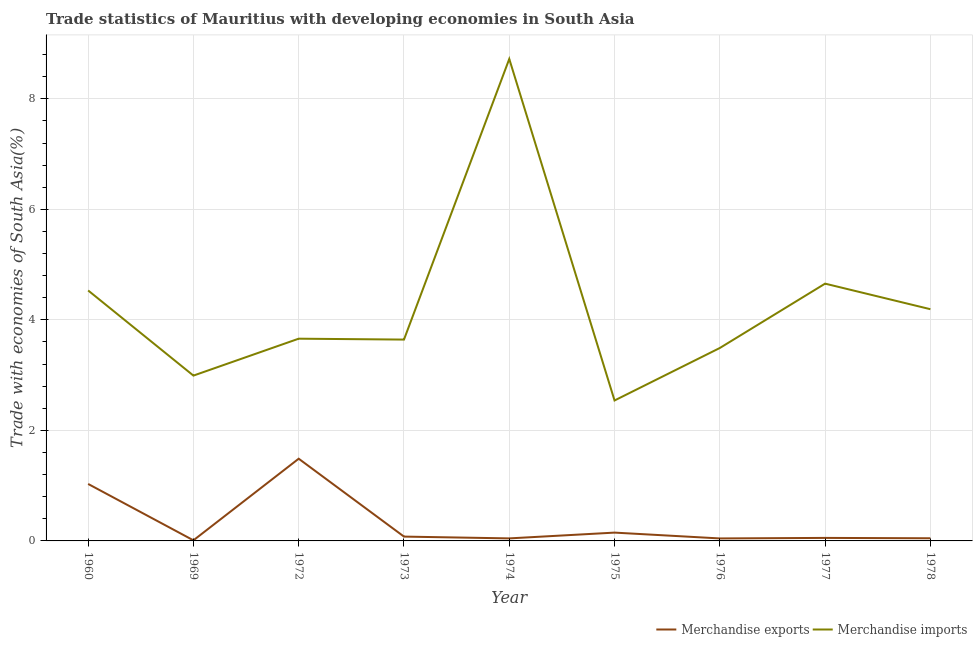What is the merchandise exports in 1974?
Keep it short and to the point. 0.05. Across all years, what is the maximum merchandise imports?
Your answer should be compact. 8.72. Across all years, what is the minimum merchandise exports?
Ensure brevity in your answer.  0.01. In which year was the merchandise exports minimum?
Keep it short and to the point. 1969. What is the total merchandise imports in the graph?
Provide a short and direct response. 38.43. What is the difference between the merchandise imports in 1974 and that in 1977?
Your response must be concise. 4.07. What is the difference between the merchandise imports in 1969 and the merchandise exports in 1977?
Your response must be concise. 2.94. What is the average merchandise imports per year?
Make the answer very short. 4.27. In the year 1974, what is the difference between the merchandise imports and merchandise exports?
Your response must be concise. 8.68. In how many years, is the merchandise exports greater than 6.4 %?
Give a very brief answer. 0. What is the ratio of the merchandise imports in 1974 to that in 1975?
Your response must be concise. 3.43. Is the merchandise exports in 1973 less than that in 1978?
Your answer should be compact. No. Is the difference between the merchandise exports in 1960 and 1973 greater than the difference between the merchandise imports in 1960 and 1973?
Provide a short and direct response. Yes. What is the difference between the highest and the second highest merchandise imports?
Offer a very short reply. 4.07. What is the difference between the highest and the lowest merchandise imports?
Keep it short and to the point. 6.18. In how many years, is the merchandise imports greater than the average merchandise imports taken over all years?
Your answer should be compact. 3. Is the sum of the merchandise imports in 1960 and 1973 greater than the maximum merchandise exports across all years?
Give a very brief answer. Yes. Does the merchandise exports monotonically increase over the years?
Your answer should be compact. No. Is the merchandise imports strictly greater than the merchandise exports over the years?
Give a very brief answer. Yes. Is the merchandise imports strictly less than the merchandise exports over the years?
Keep it short and to the point. No. Does the graph contain any zero values?
Keep it short and to the point. No. How many legend labels are there?
Your answer should be compact. 2. How are the legend labels stacked?
Give a very brief answer. Horizontal. What is the title of the graph?
Your answer should be compact. Trade statistics of Mauritius with developing economies in South Asia. Does "Merchandise imports" appear as one of the legend labels in the graph?
Ensure brevity in your answer.  Yes. What is the label or title of the Y-axis?
Your response must be concise. Trade with economies of South Asia(%). What is the Trade with economies of South Asia(%) of Merchandise exports in 1960?
Provide a short and direct response. 1.03. What is the Trade with economies of South Asia(%) of Merchandise imports in 1960?
Your answer should be very brief. 4.53. What is the Trade with economies of South Asia(%) in Merchandise exports in 1969?
Offer a terse response. 0.01. What is the Trade with economies of South Asia(%) of Merchandise imports in 1969?
Make the answer very short. 2.99. What is the Trade with economies of South Asia(%) of Merchandise exports in 1972?
Your response must be concise. 1.49. What is the Trade with economies of South Asia(%) of Merchandise imports in 1972?
Your answer should be compact. 3.66. What is the Trade with economies of South Asia(%) in Merchandise exports in 1973?
Your response must be concise. 0.08. What is the Trade with economies of South Asia(%) of Merchandise imports in 1973?
Keep it short and to the point. 3.64. What is the Trade with economies of South Asia(%) of Merchandise exports in 1974?
Your answer should be very brief. 0.05. What is the Trade with economies of South Asia(%) in Merchandise imports in 1974?
Keep it short and to the point. 8.72. What is the Trade with economies of South Asia(%) of Merchandise exports in 1975?
Keep it short and to the point. 0.15. What is the Trade with economies of South Asia(%) of Merchandise imports in 1975?
Make the answer very short. 2.54. What is the Trade with economies of South Asia(%) of Merchandise exports in 1976?
Provide a succinct answer. 0.05. What is the Trade with economies of South Asia(%) of Merchandise imports in 1976?
Ensure brevity in your answer.  3.49. What is the Trade with economies of South Asia(%) of Merchandise exports in 1977?
Provide a succinct answer. 0.05. What is the Trade with economies of South Asia(%) of Merchandise imports in 1977?
Make the answer very short. 4.66. What is the Trade with economies of South Asia(%) of Merchandise exports in 1978?
Keep it short and to the point. 0.05. What is the Trade with economies of South Asia(%) in Merchandise imports in 1978?
Offer a very short reply. 4.19. Across all years, what is the maximum Trade with economies of South Asia(%) in Merchandise exports?
Offer a very short reply. 1.49. Across all years, what is the maximum Trade with economies of South Asia(%) of Merchandise imports?
Provide a succinct answer. 8.72. Across all years, what is the minimum Trade with economies of South Asia(%) in Merchandise exports?
Offer a very short reply. 0.01. Across all years, what is the minimum Trade with economies of South Asia(%) in Merchandise imports?
Ensure brevity in your answer.  2.54. What is the total Trade with economies of South Asia(%) in Merchandise exports in the graph?
Give a very brief answer. 2.95. What is the total Trade with economies of South Asia(%) of Merchandise imports in the graph?
Give a very brief answer. 38.43. What is the difference between the Trade with economies of South Asia(%) in Merchandise exports in 1960 and that in 1969?
Your answer should be very brief. 1.02. What is the difference between the Trade with economies of South Asia(%) in Merchandise imports in 1960 and that in 1969?
Offer a terse response. 1.54. What is the difference between the Trade with economies of South Asia(%) in Merchandise exports in 1960 and that in 1972?
Your response must be concise. -0.46. What is the difference between the Trade with economies of South Asia(%) in Merchandise imports in 1960 and that in 1972?
Offer a terse response. 0.87. What is the difference between the Trade with economies of South Asia(%) in Merchandise exports in 1960 and that in 1973?
Make the answer very short. 0.95. What is the difference between the Trade with economies of South Asia(%) of Merchandise imports in 1960 and that in 1973?
Offer a terse response. 0.89. What is the difference between the Trade with economies of South Asia(%) of Merchandise exports in 1960 and that in 1974?
Your response must be concise. 0.99. What is the difference between the Trade with economies of South Asia(%) in Merchandise imports in 1960 and that in 1974?
Keep it short and to the point. -4.19. What is the difference between the Trade with economies of South Asia(%) in Merchandise exports in 1960 and that in 1975?
Ensure brevity in your answer.  0.88. What is the difference between the Trade with economies of South Asia(%) in Merchandise imports in 1960 and that in 1975?
Ensure brevity in your answer.  1.99. What is the difference between the Trade with economies of South Asia(%) of Merchandise exports in 1960 and that in 1976?
Offer a very short reply. 0.99. What is the difference between the Trade with economies of South Asia(%) of Merchandise imports in 1960 and that in 1976?
Ensure brevity in your answer.  1.04. What is the difference between the Trade with economies of South Asia(%) of Merchandise exports in 1960 and that in 1977?
Make the answer very short. 0.98. What is the difference between the Trade with economies of South Asia(%) in Merchandise imports in 1960 and that in 1977?
Offer a terse response. -0.12. What is the difference between the Trade with economies of South Asia(%) in Merchandise exports in 1960 and that in 1978?
Provide a short and direct response. 0.98. What is the difference between the Trade with economies of South Asia(%) of Merchandise imports in 1960 and that in 1978?
Give a very brief answer. 0.34. What is the difference between the Trade with economies of South Asia(%) of Merchandise exports in 1969 and that in 1972?
Your response must be concise. -1.48. What is the difference between the Trade with economies of South Asia(%) in Merchandise imports in 1969 and that in 1972?
Make the answer very short. -0.67. What is the difference between the Trade with economies of South Asia(%) of Merchandise exports in 1969 and that in 1973?
Offer a very short reply. -0.07. What is the difference between the Trade with economies of South Asia(%) of Merchandise imports in 1969 and that in 1973?
Give a very brief answer. -0.65. What is the difference between the Trade with economies of South Asia(%) of Merchandise exports in 1969 and that in 1974?
Offer a very short reply. -0.04. What is the difference between the Trade with economies of South Asia(%) in Merchandise imports in 1969 and that in 1974?
Keep it short and to the point. -5.73. What is the difference between the Trade with economies of South Asia(%) of Merchandise exports in 1969 and that in 1975?
Your answer should be very brief. -0.14. What is the difference between the Trade with economies of South Asia(%) in Merchandise imports in 1969 and that in 1975?
Give a very brief answer. 0.45. What is the difference between the Trade with economies of South Asia(%) in Merchandise exports in 1969 and that in 1976?
Offer a terse response. -0.03. What is the difference between the Trade with economies of South Asia(%) of Merchandise imports in 1969 and that in 1976?
Offer a terse response. -0.5. What is the difference between the Trade with economies of South Asia(%) of Merchandise exports in 1969 and that in 1977?
Give a very brief answer. -0.04. What is the difference between the Trade with economies of South Asia(%) in Merchandise imports in 1969 and that in 1977?
Ensure brevity in your answer.  -1.66. What is the difference between the Trade with economies of South Asia(%) in Merchandise exports in 1969 and that in 1978?
Ensure brevity in your answer.  -0.04. What is the difference between the Trade with economies of South Asia(%) of Merchandise imports in 1969 and that in 1978?
Give a very brief answer. -1.2. What is the difference between the Trade with economies of South Asia(%) in Merchandise exports in 1972 and that in 1973?
Provide a short and direct response. 1.41. What is the difference between the Trade with economies of South Asia(%) in Merchandise imports in 1972 and that in 1973?
Give a very brief answer. 0.02. What is the difference between the Trade with economies of South Asia(%) of Merchandise exports in 1972 and that in 1974?
Your response must be concise. 1.44. What is the difference between the Trade with economies of South Asia(%) of Merchandise imports in 1972 and that in 1974?
Offer a terse response. -5.06. What is the difference between the Trade with economies of South Asia(%) of Merchandise exports in 1972 and that in 1975?
Provide a short and direct response. 1.34. What is the difference between the Trade with economies of South Asia(%) in Merchandise imports in 1972 and that in 1975?
Provide a succinct answer. 1.12. What is the difference between the Trade with economies of South Asia(%) in Merchandise exports in 1972 and that in 1976?
Your answer should be very brief. 1.44. What is the difference between the Trade with economies of South Asia(%) in Merchandise imports in 1972 and that in 1976?
Make the answer very short. 0.17. What is the difference between the Trade with economies of South Asia(%) in Merchandise exports in 1972 and that in 1977?
Offer a very short reply. 1.43. What is the difference between the Trade with economies of South Asia(%) in Merchandise imports in 1972 and that in 1977?
Your response must be concise. -1. What is the difference between the Trade with economies of South Asia(%) in Merchandise exports in 1972 and that in 1978?
Make the answer very short. 1.44. What is the difference between the Trade with economies of South Asia(%) in Merchandise imports in 1972 and that in 1978?
Offer a very short reply. -0.53. What is the difference between the Trade with economies of South Asia(%) in Merchandise exports in 1973 and that in 1974?
Your answer should be very brief. 0.03. What is the difference between the Trade with economies of South Asia(%) in Merchandise imports in 1973 and that in 1974?
Your response must be concise. -5.08. What is the difference between the Trade with economies of South Asia(%) of Merchandise exports in 1973 and that in 1975?
Make the answer very short. -0.07. What is the difference between the Trade with economies of South Asia(%) of Merchandise imports in 1973 and that in 1975?
Keep it short and to the point. 1.1. What is the difference between the Trade with economies of South Asia(%) in Merchandise exports in 1973 and that in 1976?
Your response must be concise. 0.03. What is the difference between the Trade with economies of South Asia(%) in Merchandise imports in 1973 and that in 1976?
Offer a very short reply. 0.15. What is the difference between the Trade with economies of South Asia(%) in Merchandise exports in 1973 and that in 1977?
Give a very brief answer. 0.02. What is the difference between the Trade with economies of South Asia(%) in Merchandise imports in 1973 and that in 1977?
Ensure brevity in your answer.  -1.01. What is the difference between the Trade with economies of South Asia(%) in Merchandise exports in 1973 and that in 1978?
Provide a short and direct response. 0.03. What is the difference between the Trade with economies of South Asia(%) of Merchandise imports in 1973 and that in 1978?
Make the answer very short. -0.55. What is the difference between the Trade with economies of South Asia(%) in Merchandise exports in 1974 and that in 1975?
Your response must be concise. -0.1. What is the difference between the Trade with economies of South Asia(%) in Merchandise imports in 1974 and that in 1975?
Your answer should be compact. 6.18. What is the difference between the Trade with economies of South Asia(%) in Merchandise exports in 1974 and that in 1976?
Your answer should be very brief. 0. What is the difference between the Trade with economies of South Asia(%) in Merchandise imports in 1974 and that in 1976?
Your response must be concise. 5.23. What is the difference between the Trade with economies of South Asia(%) in Merchandise exports in 1974 and that in 1977?
Provide a short and direct response. -0.01. What is the difference between the Trade with economies of South Asia(%) in Merchandise imports in 1974 and that in 1977?
Your answer should be compact. 4.07. What is the difference between the Trade with economies of South Asia(%) of Merchandise exports in 1974 and that in 1978?
Keep it short and to the point. -0. What is the difference between the Trade with economies of South Asia(%) in Merchandise imports in 1974 and that in 1978?
Make the answer very short. 4.53. What is the difference between the Trade with economies of South Asia(%) of Merchandise exports in 1975 and that in 1976?
Offer a terse response. 0.11. What is the difference between the Trade with economies of South Asia(%) in Merchandise imports in 1975 and that in 1976?
Ensure brevity in your answer.  -0.95. What is the difference between the Trade with economies of South Asia(%) of Merchandise exports in 1975 and that in 1977?
Make the answer very short. 0.1. What is the difference between the Trade with economies of South Asia(%) in Merchandise imports in 1975 and that in 1977?
Ensure brevity in your answer.  -2.11. What is the difference between the Trade with economies of South Asia(%) in Merchandise exports in 1975 and that in 1978?
Your answer should be compact. 0.1. What is the difference between the Trade with economies of South Asia(%) in Merchandise imports in 1975 and that in 1978?
Offer a very short reply. -1.65. What is the difference between the Trade with economies of South Asia(%) in Merchandise exports in 1976 and that in 1977?
Your response must be concise. -0.01. What is the difference between the Trade with economies of South Asia(%) of Merchandise imports in 1976 and that in 1977?
Your answer should be very brief. -1.16. What is the difference between the Trade with economies of South Asia(%) of Merchandise exports in 1976 and that in 1978?
Your answer should be very brief. -0. What is the difference between the Trade with economies of South Asia(%) in Merchandise imports in 1976 and that in 1978?
Your response must be concise. -0.7. What is the difference between the Trade with economies of South Asia(%) of Merchandise exports in 1977 and that in 1978?
Ensure brevity in your answer.  0.01. What is the difference between the Trade with economies of South Asia(%) in Merchandise imports in 1977 and that in 1978?
Your answer should be compact. 0.46. What is the difference between the Trade with economies of South Asia(%) in Merchandise exports in 1960 and the Trade with economies of South Asia(%) in Merchandise imports in 1969?
Offer a terse response. -1.96. What is the difference between the Trade with economies of South Asia(%) in Merchandise exports in 1960 and the Trade with economies of South Asia(%) in Merchandise imports in 1972?
Make the answer very short. -2.63. What is the difference between the Trade with economies of South Asia(%) of Merchandise exports in 1960 and the Trade with economies of South Asia(%) of Merchandise imports in 1973?
Your response must be concise. -2.61. What is the difference between the Trade with economies of South Asia(%) in Merchandise exports in 1960 and the Trade with economies of South Asia(%) in Merchandise imports in 1974?
Provide a short and direct response. -7.69. What is the difference between the Trade with economies of South Asia(%) in Merchandise exports in 1960 and the Trade with economies of South Asia(%) in Merchandise imports in 1975?
Give a very brief answer. -1.51. What is the difference between the Trade with economies of South Asia(%) in Merchandise exports in 1960 and the Trade with economies of South Asia(%) in Merchandise imports in 1976?
Ensure brevity in your answer.  -2.46. What is the difference between the Trade with economies of South Asia(%) in Merchandise exports in 1960 and the Trade with economies of South Asia(%) in Merchandise imports in 1977?
Provide a short and direct response. -3.62. What is the difference between the Trade with economies of South Asia(%) of Merchandise exports in 1960 and the Trade with economies of South Asia(%) of Merchandise imports in 1978?
Your response must be concise. -3.16. What is the difference between the Trade with economies of South Asia(%) of Merchandise exports in 1969 and the Trade with economies of South Asia(%) of Merchandise imports in 1972?
Offer a terse response. -3.65. What is the difference between the Trade with economies of South Asia(%) in Merchandise exports in 1969 and the Trade with economies of South Asia(%) in Merchandise imports in 1973?
Provide a short and direct response. -3.63. What is the difference between the Trade with economies of South Asia(%) of Merchandise exports in 1969 and the Trade with economies of South Asia(%) of Merchandise imports in 1974?
Give a very brief answer. -8.71. What is the difference between the Trade with economies of South Asia(%) of Merchandise exports in 1969 and the Trade with economies of South Asia(%) of Merchandise imports in 1975?
Your answer should be compact. -2.53. What is the difference between the Trade with economies of South Asia(%) of Merchandise exports in 1969 and the Trade with economies of South Asia(%) of Merchandise imports in 1976?
Provide a short and direct response. -3.48. What is the difference between the Trade with economies of South Asia(%) of Merchandise exports in 1969 and the Trade with economies of South Asia(%) of Merchandise imports in 1977?
Provide a succinct answer. -4.64. What is the difference between the Trade with economies of South Asia(%) of Merchandise exports in 1969 and the Trade with economies of South Asia(%) of Merchandise imports in 1978?
Your response must be concise. -4.18. What is the difference between the Trade with economies of South Asia(%) in Merchandise exports in 1972 and the Trade with economies of South Asia(%) in Merchandise imports in 1973?
Offer a very short reply. -2.16. What is the difference between the Trade with economies of South Asia(%) in Merchandise exports in 1972 and the Trade with economies of South Asia(%) in Merchandise imports in 1974?
Offer a very short reply. -7.23. What is the difference between the Trade with economies of South Asia(%) in Merchandise exports in 1972 and the Trade with economies of South Asia(%) in Merchandise imports in 1975?
Your answer should be compact. -1.05. What is the difference between the Trade with economies of South Asia(%) in Merchandise exports in 1972 and the Trade with economies of South Asia(%) in Merchandise imports in 1976?
Provide a short and direct response. -2. What is the difference between the Trade with economies of South Asia(%) in Merchandise exports in 1972 and the Trade with economies of South Asia(%) in Merchandise imports in 1977?
Your answer should be very brief. -3.17. What is the difference between the Trade with economies of South Asia(%) of Merchandise exports in 1972 and the Trade with economies of South Asia(%) of Merchandise imports in 1978?
Ensure brevity in your answer.  -2.71. What is the difference between the Trade with economies of South Asia(%) of Merchandise exports in 1973 and the Trade with economies of South Asia(%) of Merchandise imports in 1974?
Provide a succinct answer. -8.64. What is the difference between the Trade with economies of South Asia(%) in Merchandise exports in 1973 and the Trade with economies of South Asia(%) in Merchandise imports in 1975?
Your response must be concise. -2.46. What is the difference between the Trade with economies of South Asia(%) in Merchandise exports in 1973 and the Trade with economies of South Asia(%) in Merchandise imports in 1976?
Ensure brevity in your answer.  -3.41. What is the difference between the Trade with economies of South Asia(%) in Merchandise exports in 1973 and the Trade with economies of South Asia(%) in Merchandise imports in 1977?
Offer a terse response. -4.58. What is the difference between the Trade with economies of South Asia(%) of Merchandise exports in 1973 and the Trade with economies of South Asia(%) of Merchandise imports in 1978?
Your response must be concise. -4.11. What is the difference between the Trade with economies of South Asia(%) in Merchandise exports in 1974 and the Trade with economies of South Asia(%) in Merchandise imports in 1975?
Your answer should be very brief. -2.5. What is the difference between the Trade with economies of South Asia(%) in Merchandise exports in 1974 and the Trade with economies of South Asia(%) in Merchandise imports in 1976?
Offer a terse response. -3.45. What is the difference between the Trade with economies of South Asia(%) of Merchandise exports in 1974 and the Trade with economies of South Asia(%) of Merchandise imports in 1977?
Ensure brevity in your answer.  -4.61. What is the difference between the Trade with economies of South Asia(%) of Merchandise exports in 1974 and the Trade with economies of South Asia(%) of Merchandise imports in 1978?
Make the answer very short. -4.15. What is the difference between the Trade with economies of South Asia(%) of Merchandise exports in 1975 and the Trade with economies of South Asia(%) of Merchandise imports in 1976?
Keep it short and to the point. -3.34. What is the difference between the Trade with economies of South Asia(%) of Merchandise exports in 1975 and the Trade with economies of South Asia(%) of Merchandise imports in 1977?
Ensure brevity in your answer.  -4.51. What is the difference between the Trade with economies of South Asia(%) of Merchandise exports in 1975 and the Trade with economies of South Asia(%) of Merchandise imports in 1978?
Make the answer very short. -4.04. What is the difference between the Trade with economies of South Asia(%) in Merchandise exports in 1976 and the Trade with economies of South Asia(%) in Merchandise imports in 1977?
Your response must be concise. -4.61. What is the difference between the Trade with economies of South Asia(%) of Merchandise exports in 1976 and the Trade with economies of South Asia(%) of Merchandise imports in 1978?
Keep it short and to the point. -4.15. What is the difference between the Trade with economies of South Asia(%) of Merchandise exports in 1977 and the Trade with economies of South Asia(%) of Merchandise imports in 1978?
Your response must be concise. -4.14. What is the average Trade with economies of South Asia(%) of Merchandise exports per year?
Your answer should be very brief. 0.33. What is the average Trade with economies of South Asia(%) of Merchandise imports per year?
Make the answer very short. 4.27. In the year 1960, what is the difference between the Trade with economies of South Asia(%) in Merchandise exports and Trade with economies of South Asia(%) in Merchandise imports?
Offer a terse response. -3.5. In the year 1969, what is the difference between the Trade with economies of South Asia(%) in Merchandise exports and Trade with economies of South Asia(%) in Merchandise imports?
Offer a very short reply. -2.98. In the year 1972, what is the difference between the Trade with economies of South Asia(%) of Merchandise exports and Trade with economies of South Asia(%) of Merchandise imports?
Your answer should be very brief. -2.17. In the year 1973, what is the difference between the Trade with economies of South Asia(%) of Merchandise exports and Trade with economies of South Asia(%) of Merchandise imports?
Offer a terse response. -3.57. In the year 1974, what is the difference between the Trade with economies of South Asia(%) of Merchandise exports and Trade with economies of South Asia(%) of Merchandise imports?
Keep it short and to the point. -8.68. In the year 1975, what is the difference between the Trade with economies of South Asia(%) of Merchandise exports and Trade with economies of South Asia(%) of Merchandise imports?
Keep it short and to the point. -2.39. In the year 1976, what is the difference between the Trade with economies of South Asia(%) of Merchandise exports and Trade with economies of South Asia(%) of Merchandise imports?
Your response must be concise. -3.45. In the year 1977, what is the difference between the Trade with economies of South Asia(%) of Merchandise exports and Trade with economies of South Asia(%) of Merchandise imports?
Provide a succinct answer. -4.6. In the year 1978, what is the difference between the Trade with economies of South Asia(%) of Merchandise exports and Trade with economies of South Asia(%) of Merchandise imports?
Offer a terse response. -4.15. What is the ratio of the Trade with economies of South Asia(%) in Merchandise exports in 1960 to that in 1969?
Provide a succinct answer. 95.76. What is the ratio of the Trade with economies of South Asia(%) of Merchandise imports in 1960 to that in 1969?
Keep it short and to the point. 1.51. What is the ratio of the Trade with economies of South Asia(%) in Merchandise exports in 1960 to that in 1972?
Give a very brief answer. 0.69. What is the ratio of the Trade with economies of South Asia(%) in Merchandise imports in 1960 to that in 1972?
Ensure brevity in your answer.  1.24. What is the ratio of the Trade with economies of South Asia(%) of Merchandise exports in 1960 to that in 1973?
Give a very brief answer. 13.15. What is the ratio of the Trade with economies of South Asia(%) of Merchandise imports in 1960 to that in 1973?
Offer a very short reply. 1.24. What is the ratio of the Trade with economies of South Asia(%) in Merchandise exports in 1960 to that in 1974?
Keep it short and to the point. 22.52. What is the ratio of the Trade with economies of South Asia(%) in Merchandise imports in 1960 to that in 1974?
Ensure brevity in your answer.  0.52. What is the ratio of the Trade with economies of South Asia(%) in Merchandise exports in 1960 to that in 1975?
Ensure brevity in your answer.  6.86. What is the ratio of the Trade with economies of South Asia(%) in Merchandise imports in 1960 to that in 1975?
Offer a terse response. 1.78. What is the ratio of the Trade with economies of South Asia(%) of Merchandise exports in 1960 to that in 1976?
Your response must be concise. 22.87. What is the ratio of the Trade with economies of South Asia(%) of Merchandise imports in 1960 to that in 1976?
Provide a short and direct response. 1.3. What is the ratio of the Trade with economies of South Asia(%) of Merchandise exports in 1960 to that in 1977?
Keep it short and to the point. 18.91. What is the ratio of the Trade with economies of South Asia(%) in Merchandise imports in 1960 to that in 1977?
Provide a succinct answer. 0.97. What is the ratio of the Trade with economies of South Asia(%) of Merchandise exports in 1960 to that in 1978?
Your answer should be very brief. 21.48. What is the ratio of the Trade with economies of South Asia(%) in Merchandise imports in 1960 to that in 1978?
Ensure brevity in your answer.  1.08. What is the ratio of the Trade with economies of South Asia(%) in Merchandise exports in 1969 to that in 1972?
Offer a terse response. 0.01. What is the ratio of the Trade with economies of South Asia(%) of Merchandise imports in 1969 to that in 1972?
Offer a terse response. 0.82. What is the ratio of the Trade with economies of South Asia(%) of Merchandise exports in 1969 to that in 1973?
Give a very brief answer. 0.14. What is the ratio of the Trade with economies of South Asia(%) in Merchandise imports in 1969 to that in 1973?
Your answer should be very brief. 0.82. What is the ratio of the Trade with economies of South Asia(%) of Merchandise exports in 1969 to that in 1974?
Your answer should be compact. 0.24. What is the ratio of the Trade with economies of South Asia(%) of Merchandise imports in 1969 to that in 1974?
Your response must be concise. 0.34. What is the ratio of the Trade with economies of South Asia(%) in Merchandise exports in 1969 to that in 1975?
Provide a short and direct response. 0.07. What is the ratio of the Trade with economies of South Asia(%) in Merchandise imports in 1969 to that in 1975?
Your answer should be very brief. 1.18. What is the ratio of the Trade with economies of South Asia(%) of Merchandise exports in 1969 to that in 1976?
Make the answer very short. 0.24. What is the ratio of the Trade with economies of South Asia(%) in Merchandise imports in 1969 to that in 1976?
Provide a short and direct response. 0.86. What is the ratio of the Trade with economies of South Asia(%) of Merchandise exports in 1969 to that in 1977?
Provide a short and direct response. 0.2. What is the ratio of the Trade with economies of South Asia(%) in Merchandise imports in 1969 to that in 1977?
Your answer should be compact. 0.64. What is the ratio of the Trade with economies of South Asia(%) in Merchandise exports in 1969 to that in 1978?
Provide a short and direct response. 0.22. What is the ratio of the Trade with economies of South Asia(%) in Merchandise imports in 1969 to that in 1978?
Give a very brief answer. 0.71. What is the ratio of the Trade with economies of South Asia(%) in Merchandise exports in 1972 to that in 1973?
Offer a very short reply. 18.98. What is the ratio of the Trade with economies of South Asia(%) of Merchandise exports in 1972 to that in 1974?
Provide a succinct answer. 32.5. What is the ratio of the Trade with economies of South Asia(%) of Merchandise imports in 1972 to that in 1974?
Offer a very short reply. 0.42. What is the ratio of the Trade with economies of South Asia(%) of Merchandise exports in 1972 to that in 1975?
Give a very brief answer. 9.89. What is the ratio of the Trade with economies of South Asia(%) of Merchandise imports in 1972 to that in 1975?
Offer a very short reply. 1.44. What is the ratio of the Trade with economies of South Asia(%) in Merchandise exports in 1972 to that in 1976?
Your answer should be compact. 33.01. What is the ratio of the Trade with economies of South Asia(%) in Merchandise imports in 1972 to that in 1976?
Your answer should be very brief. 1.05. What is the ratio of the Trade with economies of South Asia(%) of Merchandise exports in 1972 to that in 1977?
Provide a short and direct response. 27.29. What is the ratio of the Trade with economies of South Asia(%) in Merchandise imports in 1972 to that in 1977?
Give a very brief answer. 0.79. What is the ratio of the Trade with economies of South Asia(%) of Merchandise exports in 1972 to that in 1978?
Keep it short and to the point. 30.99. What is the ratio of the Trade with economies of South Asia(%) of Merchandise imports in 1972 to that in 1978?
Give a very brief answer. 0.87. What is the ratio of the Trade with economies of South Asia(%) in Merchandise exports in 1973 to that in 1974?
Give a very brief answer. 1.71. What is the ratio of the Trade with economies of South Asia(%) of Merchandise imports in 1973 to that in 1974?
Offer a very short reply. 0.42. What is the ratio of the Trade with economies of South Asia(%) of Merchandise exports in 1973 to that in 1975?
Provide a short and direct response. 0.52. What is the ratio of the Trade with economies of South Asia(%) of Merchandise imports in 1973 to that in 1975?
Make the answer very short. 1.43. What is the ratio of the Trade with economies of South Asia(%) in Merchandise exports in 1973 to that in 1976?
Give a very brief answer. 1.74. What is the ratio of the Trade with economies of South Asia(%) of Merchandise imports in 1973 to that in 1976?
Provide a short and direct response. 1.04. What is the ratio of the Trade with economies of South Asia(%) of Merchandise exports in 1973 to that in 1977?
Your answer should be very brief. 1.44. What is the ratio of the Trade with economies of South Asia(%) of Merchandise imports in 1973 to that in 1977?
Make the answer very short. 0.78. What is the ratio of the Trade with economies of South Asia(%) of Merchandise exports in 1973 to that in 1978?
Offer a very short reply. 1.63. What is the ratio of the Trade with economies of South Asia(%) in Merchandise imports in 1973 to that in 1978?
Offer a very short reply. 0.87. What is the ratio of the Trade with economies of South Asia(%) in Merchandise exports in 1974 to that in 1975?
Provide a succinct answer. 0.3. What is the ratio of the Trade with economies of South Asia(%) in Merchandise imports in 1974 to that in 1975?
Provide a succinct answer. 3.43. What is the ratio of the Trade with economies of South Asia(%) in Merchandise exports in 1974 to that in 1976?
Provide a short and direct response. 1.02. What is the ratio of the Trade with economies of South Asia(%) of Merchandise imports in 1974 to that in 1976?
Your answer should be compact. 2.5. What is the ratio of the Trade with economies of South Asia(%) in Merchandise exports in 1974 to that in 1977?
Keep it short and to the point. 0.84. What is the ratio of the Trade with economies of South Asia(%) of Merchandise imports in 1974 to that in 1977?
Keep it short and to the point. 1.87. What is the ratio of the Trade with economies of South Asia(%) of Merchandise exports in 1974 to that in 1978?
Make the answer very short. 0.95. What is the ratio of the Trade with economies of South Asia(%) of Merchandise imports in 1974 to that in 1978?
Provide a short and direct response. 2.08. What is the ratio of the Trade with economies of South Asia(%) in Merchandise exports in 1975 to that in 1976?
Offer a very short reply. 3.34. What is the ratio of the Trade with economies of South Asia(%) of Merchandise imports in 1975 to that in 1976?
Your answer should be compact. 0.73. What is the ratio of the Trade with economies of South Asia(%) of Merchandise exports in 1975 to that in 1977?
Your answer should be very brief. 2.76. What is the ratio of the Trade with economies of South Asia(%) of Merchandise imports in 1975 to that in 1977?
Offer a very short reply. 0.55. What is the ratio of the Trade with economies of South Asia(%) of Merchandise exports in 1975 to that in 1978?
Offer a terse response. 3.13. What is the ratio of the Trade with economies of South Asia(%) in Merchandise imports in 1975 to that in 1978?
Ensure brevity in your answer.  0.61. What is the ratio of the Trade with economies of South Asia(%) of Merchandise exports in 1976 to that in 1977?
Provide a succinct answer. 0.83. What is the ratio of the Trade with economies of South Asia(%) in Merchandise imports in 1976 to that in 1977?
Offer a terse response. 0.75. What is the ratio of the Trade with economies of South Asia(%) in Merchandise exports in 1976 to that in 1978?
Keep it short and to the point. 0.94. What is the ratio of the Trade with economies of South Asia(%) of Merchandise imports in 1976 to that in 1978?
Your response must be concise. 0.83. What is the ratio of the Trade with economies of South Asia(%) of Merchandise exports in 1977 to that in 1978?
Ensure brevity in your answer.  1.14. What is the ratio of the Trade with economies of South Asia(%) in Merchandise imports in 1977 to that in 1978?
Offer a terse response. 1.11. What is the difference between the highest and the second highest Trade with economies of South Asia(%) in Merchandise exports?
Your response must be concise. 0.46. What is the difference between the highest and the second highest Trade with economies of South Asia(%) in Merchandise imports?
Offer a very short reply. 4.07. What is the difference between the highest and the lowest Trade with economies of South Asia(%) of Merchandise exports?
Offer a very short reply. 1.48. What is the difference between the highest and the lowest Trade with economies of South Asia(%) of Merchandise imports?
Give a very brief answer. 6.18. 